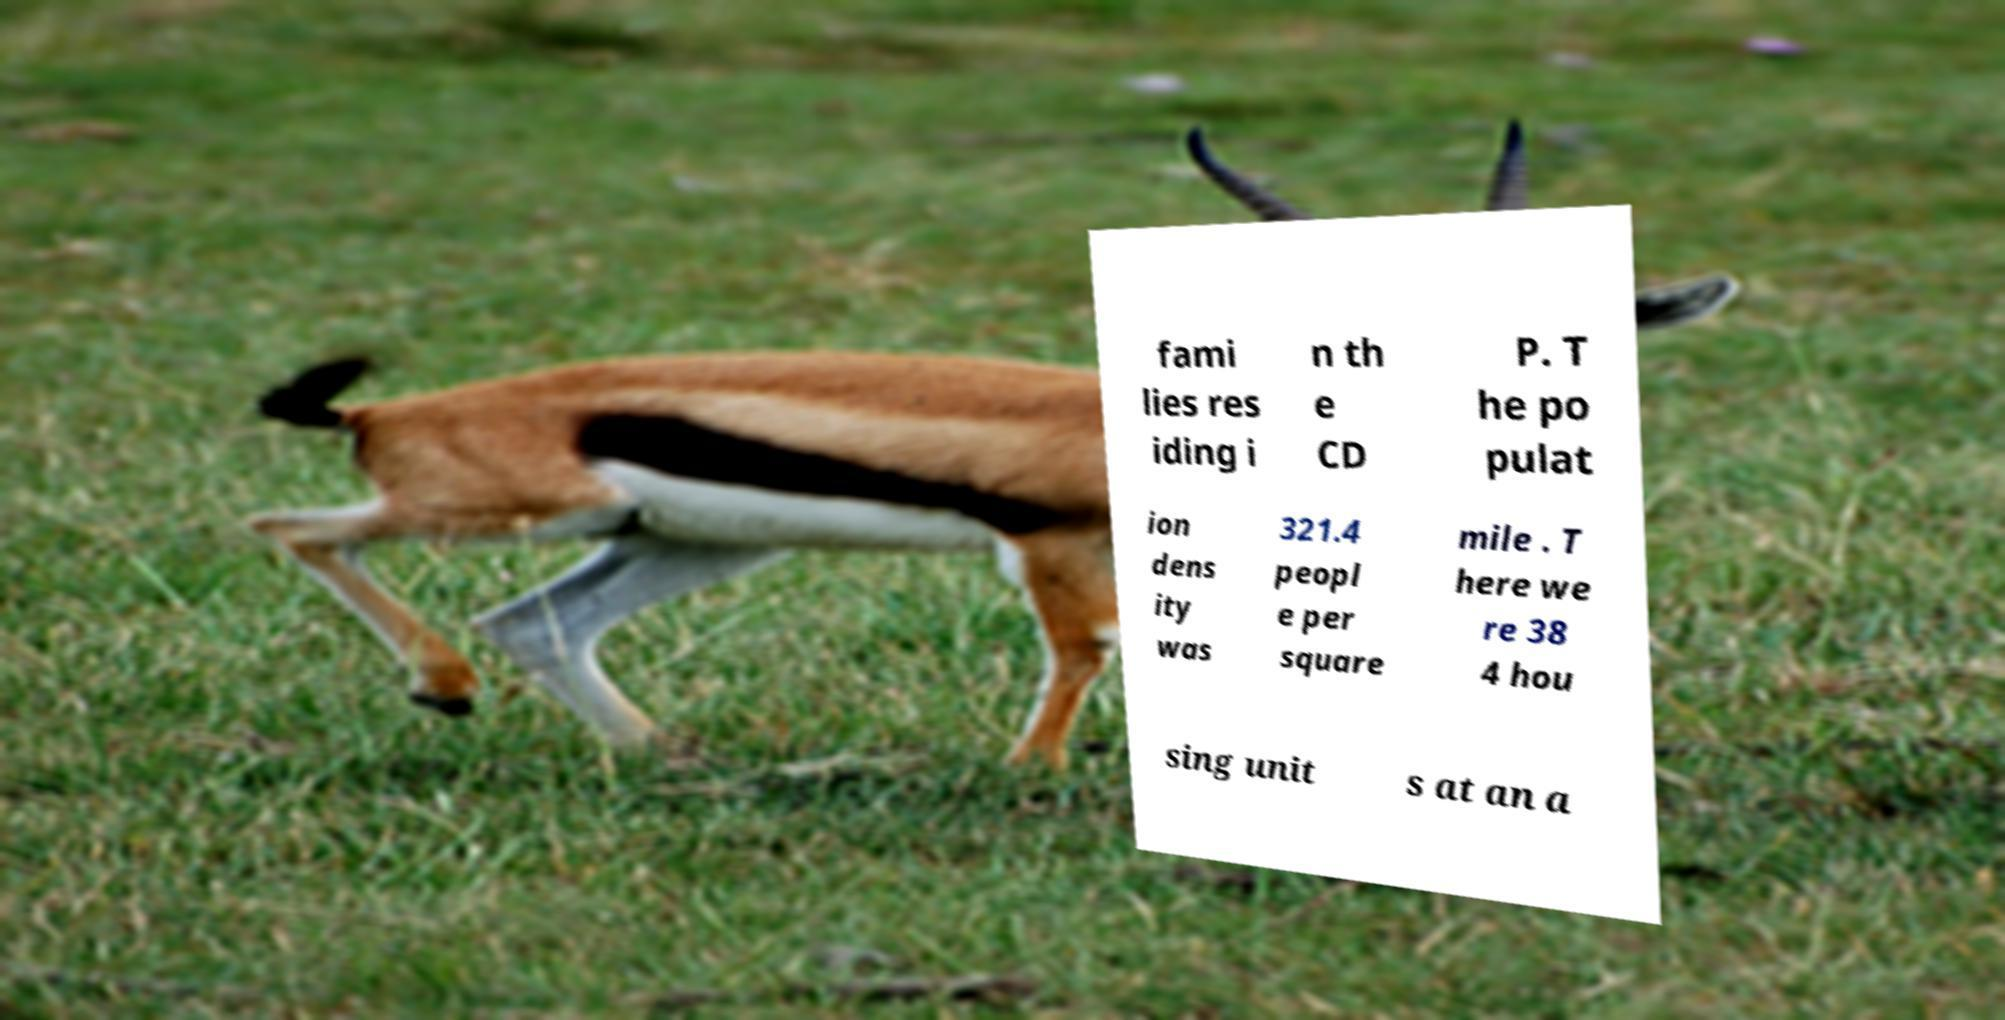Can you accurately transcribe the text from the provided image for me? fami lies res iding i n th e CD P. T he po pulat ion dens ity was 321.4 peopl e per square mile . T here we re 38 4 hou sing unit s at an a 